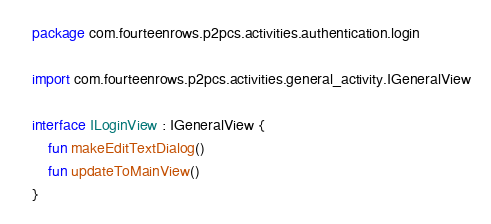<code> <loc_0><loc_0><loc_500><loc_500><_Kotlin_>package com.fourteenrows.p2pcs.activities.authentication.login

import com.fourteenrows.p2pcs.activities.general_activity.IGeneralView

interface ILoginView : IGeneralView {
    fun makeEditTextDialog()
    fun updateToMainView()
}</code> 